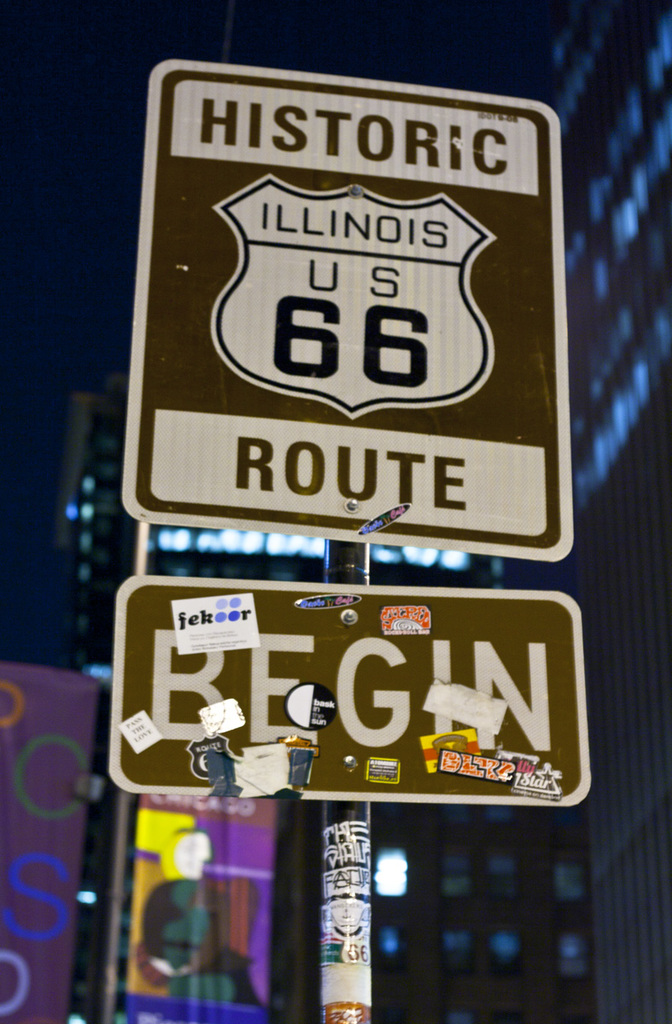What details can you tell me about the stickers and graffiti on the Route 66 sign? The stickers and graffiti on the Route 66 sign are testimonials to the many visitors who have passed through this spot. Each sticker and tag represents someone's personal journey, adding a human element to the historical significance of the route. From souvenir decals to handwritten messages, these markings tell a rich story of travel, adventure, and personal expression, turning the sign into a dynamic artifact of collective memories. 